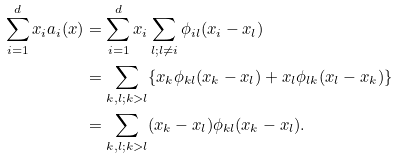<formula> <loc_0><loc_0><loc_500><loc_500>\sum _ { i = 1 } ^ { d } x _ { i } a _ { i } ( x ) & = \sum _ { i = 1 } ^ { d } x _ { i } \sum _ { l ; l \neq i } \phi _ { i l } ( x _ { i } - x _ { l } ) \\ & = \sum _ { k , l ; k > l } \{ x _ { k } \phi _ { k l } ( x _ { k } - x _ { l } ) + x _ { l } \phi _ { l k } ( x _ { l } - x _ { k } ) \} \\ & = \sum _ { k , l ; k > l } ( x _ { k } - x _ { l } ) \phi _ { k l } ( x _ { k } - x _ { l } ) .</formula> 